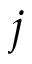Convert formula to latex. <formula><loc_0><loc_0><loc_500><loc_500>j</formula> 